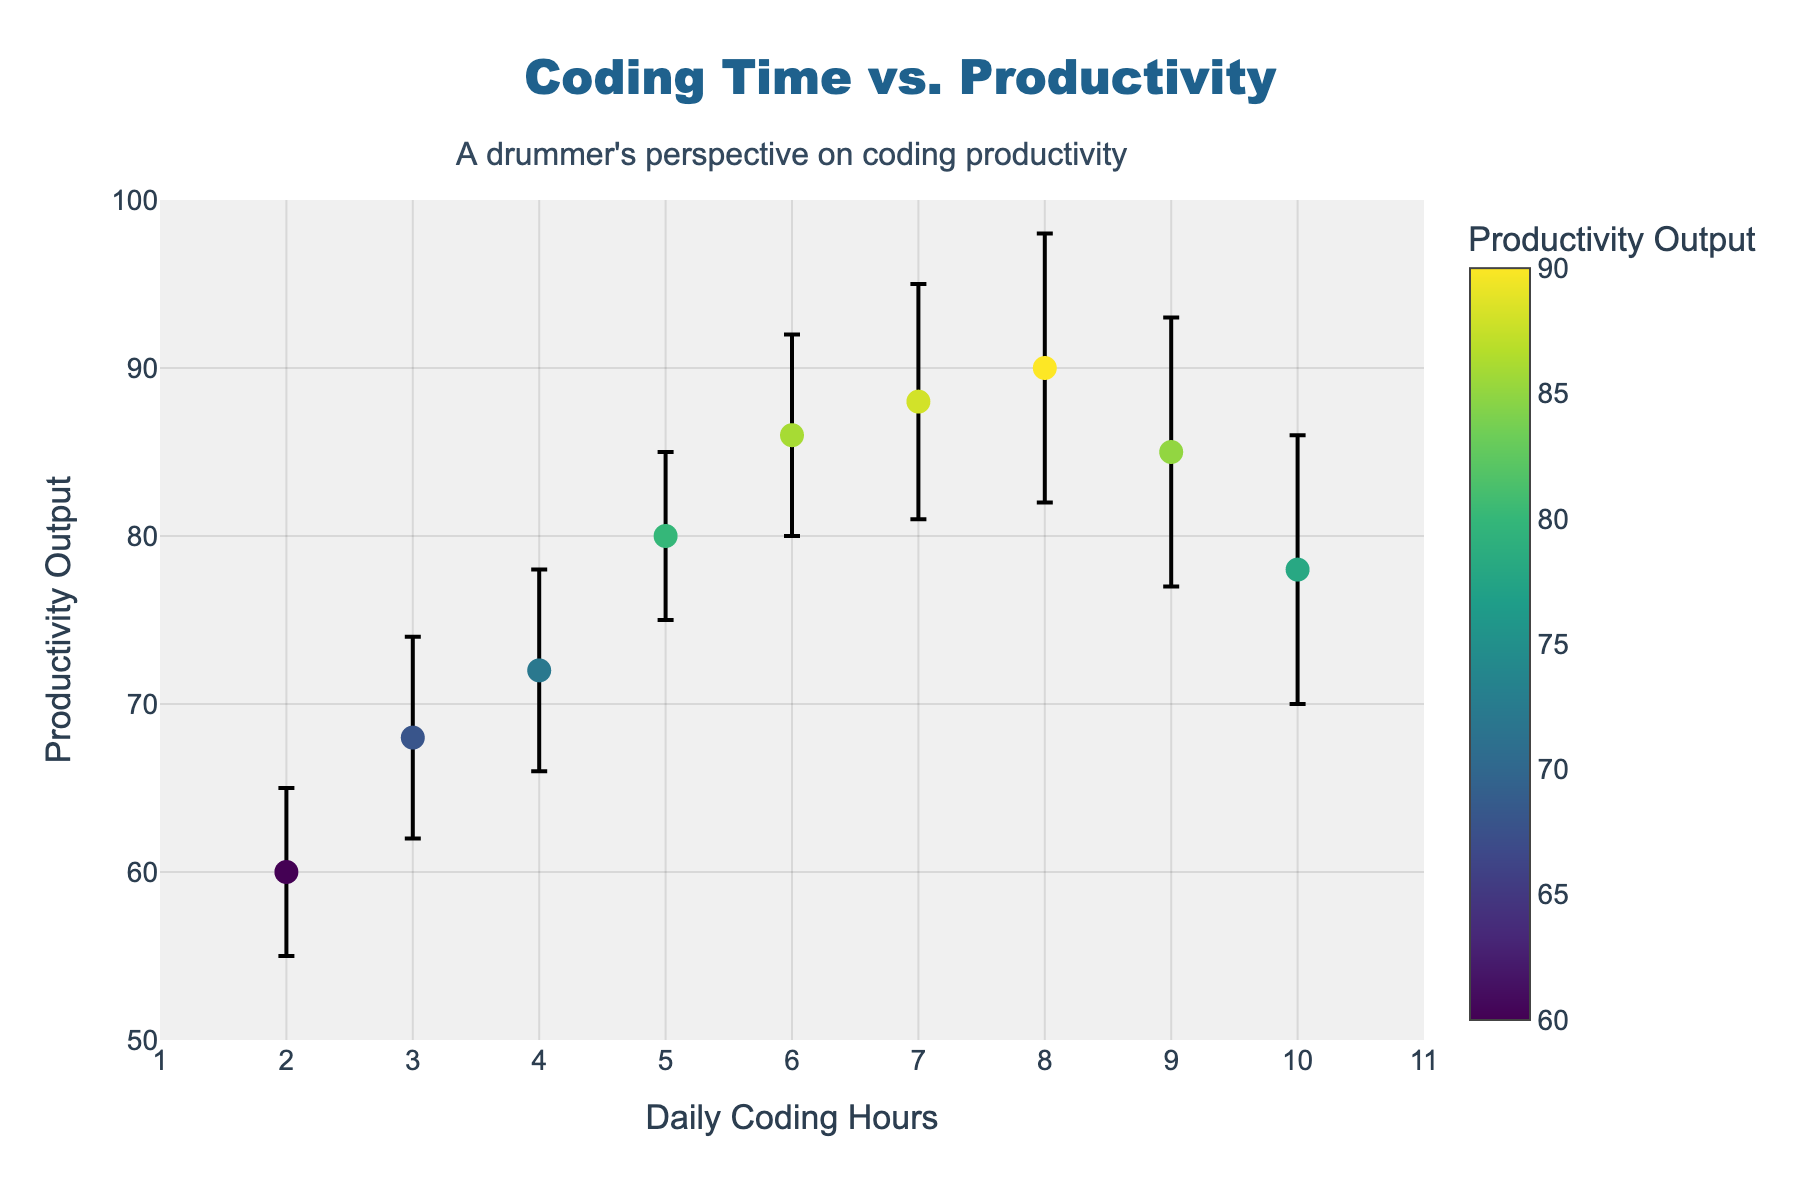What's the title of the figure? The title is prominently displayed at the top center of the figure. It reads "Coding Time vs. Productivity".
Answer: Coding Time vs. Productivity How many daily coding hours are recorded in the data? The x-axis displays the daily coding hours ranging from 2 to 10. By counting the markers, we can see there are values for 9 different days.
Answer: 9 What is the productivity output for 7 daily coding hours? Locate the x-axis value at 7 coding hours, then trace upwards to the corresponding marker. The y-axis value for that marker is 88.
Answer: 88 Which data point has the highest productivity output? By looking at the y-axis, the highest productivity output is 90, which corresponds to 8 daily coding hours.
Answer: 8 daily coding hours What is the range of productivity output values for 5 daily coding hours? For 5 daily coding hours, the marker's y-value is 80. The error bar ranges from 75 to 85.
Answer: 75 to 85 What is the difference in productivity output between coding for 4 hours and 10 hours per day? The productivity output for 4 hours is 72, while for 10 hours it is 78. The difference is 78 - 72 = 6.
Answer: 6 Which daily coding hour has the largest variation in reported productivity levels? Compare the lengths of the error bars for each coding hour. The error bar at 2 hours has the largest range: 65 - 55 = 10.
Answer: 2 daily coding hours Is there a general trend in productivity output as daily coding hours increase? Observing the data points from left to right, productivity generally increases up to 8 hours of coding, then declines at 9 and 10 hours.
Answer: Initially increases, then declines What is the median productivity output for the data points shown? List the productivity outputs in ascending order: 60, 68, 72, 78, 80, 85, 86, 88, 90. The median value is the middle one, which is 80.
Answer: 80 What is the average productivity output between 2 and 8 daily coding hours? Sum the productivity outputs for coding hours 2 to 8: 60 + 68 + 72 + 80 + 86 + 88 + 90 = 544, and divide by 7 data points: 544 / 7 ≈ 77.71.
Answer: 77.71 